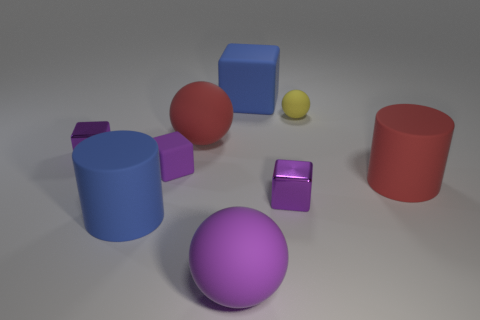What is the material of the thing that is the same color as the large matte block?
Make the answer very short. Rubber. The cylinder on the right side of the red matte thing that is on the left side of the purple sphere is made of what material?
Ensure brevity in your answer.  Rubber. What material is the large purple thing that is the same shape as the tiny yellow matte object?
Keep it short and to the point. Rubber. There is a rubber ball that is behind the red ball; does it have the same size as the blue cylinder?
Give a very brief answer. No. How many shiny things are either small yellow things or small cyan cylinders?
Give a very brief answer. 0. There is a big thing that is both to the left of the large rubber cube and behind the blue cylinder; what material is it?
Offer a terse response. Rubber. Do the small yellow thing and the blue cube have the same material?
Make the answer very short. Yes. How big is the rubber sphere that is both behind the large purple rubber thing and to the left of the blue rubber block?
Your response must be concise. Large. What is the shape of the tiny yellow rubber thing?
Ensure brevity in your answer.  Sphere. How many things are either small purple objects or blue rubber things behind the tiny rubber sphere?
Your answer should be compact. 4. 